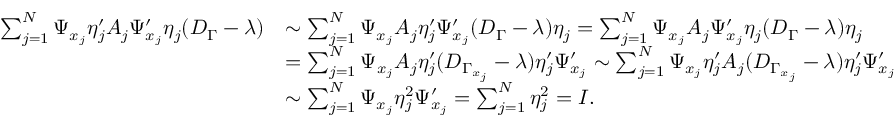Convert formula to latex. <formula><loc_0><loc_0><loc_500><loc_500>\begin{array} { r l } { \sum _ { j = 1 } ^ { N } \Psi _ { x _ { j } } \eta _ { j } ^ { \prime } A _ { j } \Psi _ { x _ { j } } ^ { \prime } \eta _ { j } ( D _ { \Gamma } - \lambda ) } & { \sim \sum _ { j = 1 } ^ { N } \Psi _ { x _ { j } } A _ { j } \eta _ { j } ^ { \prime } \Psi _ { x _ { j } } ^ { \prime } ( D _ { \Gamma } - \lambda ) \eta _ { j } = \sum _ { j = 1 } ^ { N } \Psi _ { x _ { j } } A _ { j } \Psi _ { x _ { j } } ^ { \prime } \eta _ { j } ( D _ { \Gamma } - \lambda ) \eta _ { j } } \\ & { = \sum _ { j = 1 } ^ { N } \Psi _ { x _ { j } } A _ { j } \eta _ { j } ^ { \prime } ( D _ { \Gamma _ { x _ { j } } } - \lambda ) \eta _ { j } ^ { \prime } \Psi _ { x _ { j } } ^ { \prime } \sim \sum _ { j = 1 } ^ { N } \Psi _ { x _ { j } } \eta _ { j } ^ { \prime } A _ { j } ( D _ { \Gamma _ { x _ { j } } } - \lambda ) \eta _ { j } ^ { \prime } \Psi _ { x _ { j } } ^ { \prime } } \\ & { \sim \sum _ { j = 1 } ^ { N } \Psi _ { x _ { j } } \eta _ { j } ^ { 2 } \Psi _ { x _ { j } } ^ { \prime } = \sum _ { j = 1 } ^ { N } \eta _ { j } ^ { 2 } = I . } \end{array}</formula> 